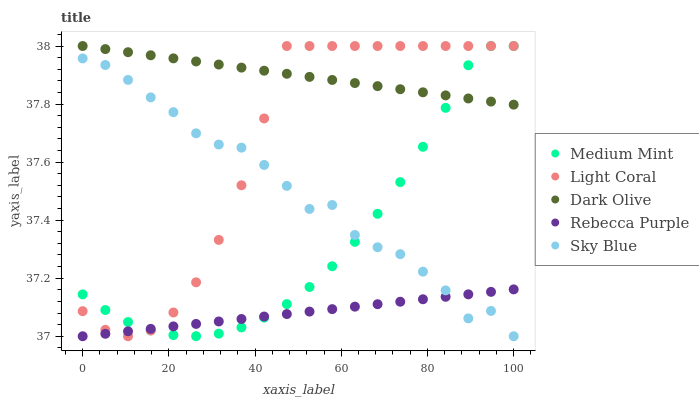Does Rebecca Purple have the minimum area under the curve?
Answer yes or no. Yes. Does Dark Olive have the maximum area under the curve?
Answer yes or no. Yes. Does Light Coral have the minimum area under the curve?
Answer yes or no. No. Does Light Coral have the maximum area under the curve?
Answer yes or no. No. Is Rebecca Purple the smoothest?
Answer yes or no. Yes. Is Sky Blue the roughest?
Answer yes or no. Yes. Is Light Coral the smoothest?
Answer yes or no. No. Is Light Coral the roughest?
Answer yes or no. No. Does Rebecca Purple have the lowest value?
Answer yes or no. Yes. Does Light Coral have the lowest value?
Answer yes or no. No. Does Dark Olive have the highest value?
Answer yes or no. Yes. Does Rebecca Purple have the highest value?
Answer yes or no. No. Is Sky Blue less than Dark Olive?
Answer yes or no. Yes. Is Dark Olive greater than Sky Blue?
Answer yes or no. Yes. Does Medium Mint intersect Sky Blue?
Answer yes or no. Yes. Is Medium Mint less than Sky Blue?
Answer yes or no. No. Is Medium Mint greater than Sky Blue?
Answer yes or no. No. Does Sky Blue intersect Dark Olive?
Answer yes or no. No. 